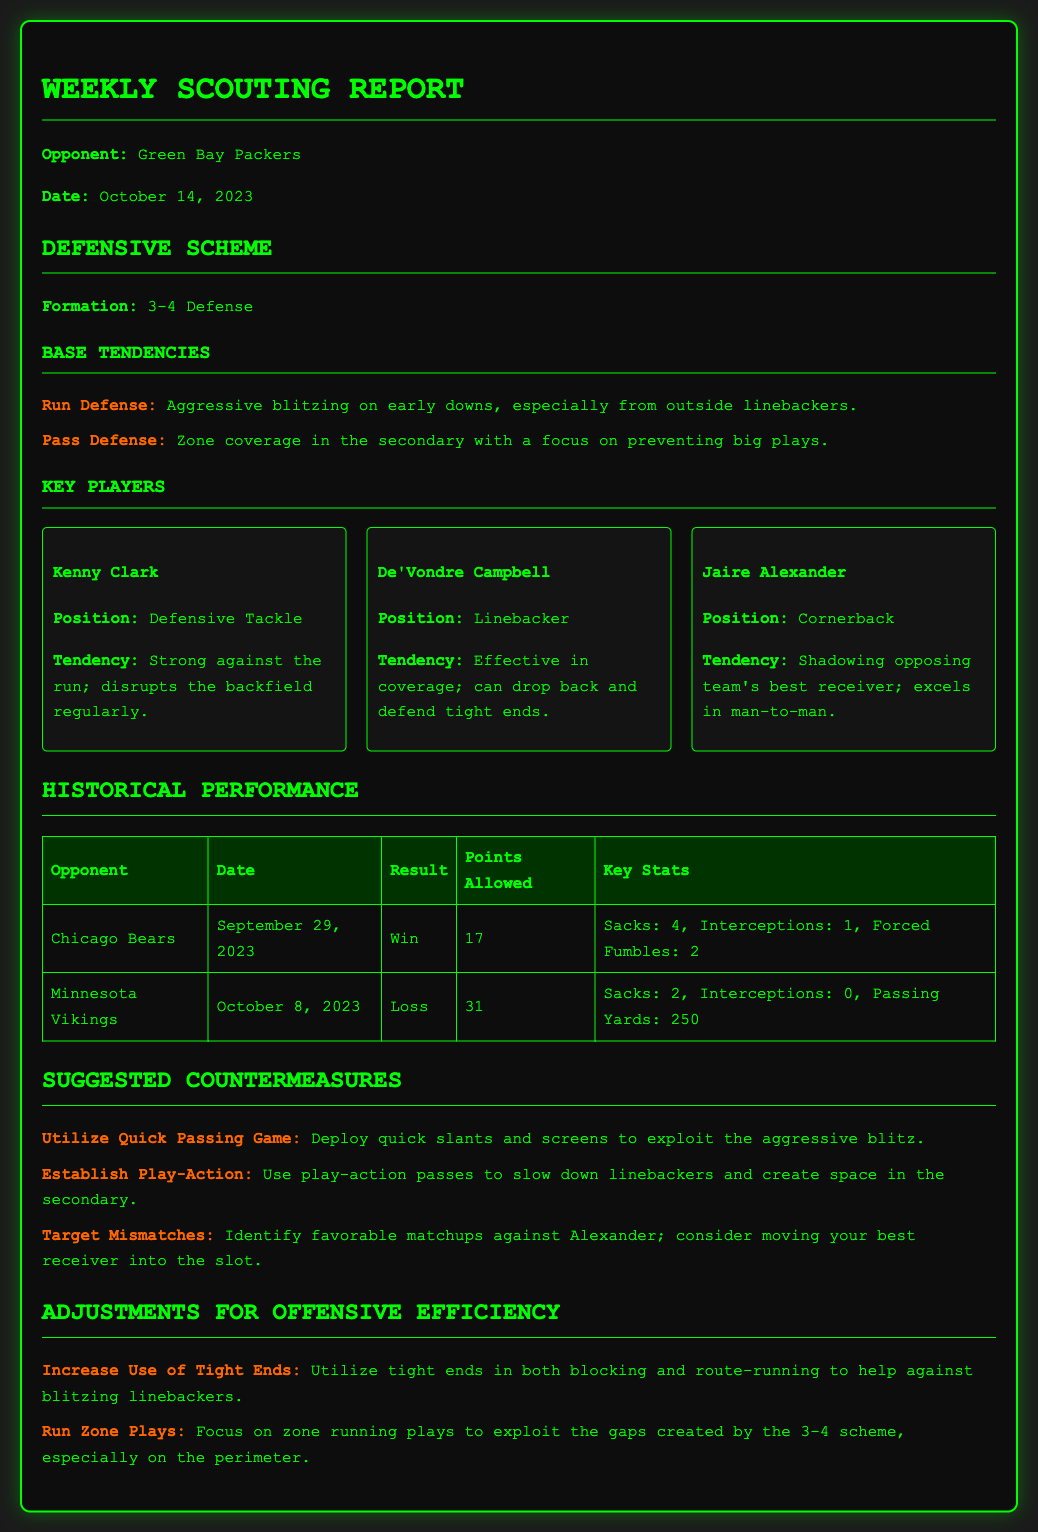What is the opponent's name? The opponent's name is indicated in the report's title under "Opponent", which is "Green Bay Packers".
Answer: Green Bay Packers What is the date of the report? The date is specified in the report under "Date", which is indicated as "October 14, 2023".
Answer: October 14, 2023 What defensive formation does the opponent use? The formation is found under "Defensive Scheme", where it states the opponent uses a "3-4 Defense".
Answer: 3-4 Defense Who is the cornerback for the opposing team? The report lists players under "Key Players", where it identifies "Jaire Alexander" as the cornerback.
Answer: Jaire Alexander How many points did the Packers allow in their game against the Minnesota Vikings? The information is found in the "Historical Performance" section, indicating the number of points allowed in that game is "31".
Answer: 31 What suggested countermeasure involves tight ends? The suggested countermeasure can be found under "Suggested Countermeasures" which mentions using tight ends for increased efficiency.
Answer: Increase Use of Tight Ends What was the result of the game against the Chicago Bears? The result is listed in "Historical Performance", specifically stating the outcome was a "Win".
Answer: Win Which statistic was notable in the game against the Minnesota Vikings? The "Key Stats" section under "Historical Performance" highlights important statistics, mentioning "Passing Yards: 250" as notable.
Answer: Passing Yards: 250 What is one adjustment suggested for offensive efficiency? The adjustments section provides strategies, mentioning "Run Zone Plays" as a suggested adjustment for improving efficiency.
Answer: Run Zone Plays 